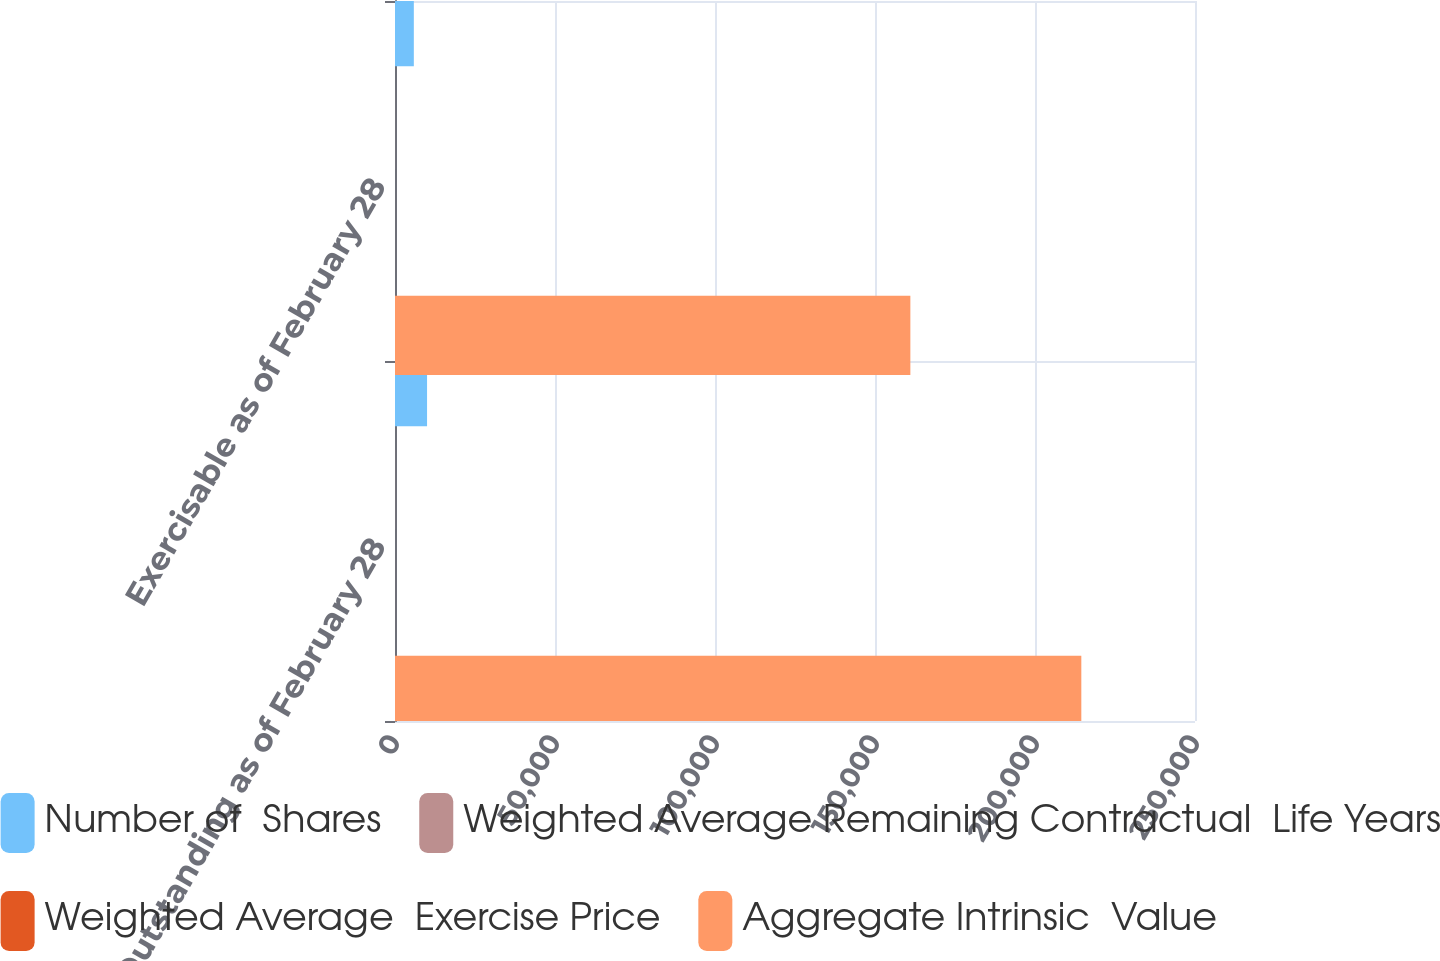<chart> <loc_0><loc_0><loc_500><loc_500><stacked_bar_chart><ecel><fcel>Outstanding as of February 28<fcel>Exercisable as of February 28<nl><fcel>Number of  Shares<fcel>10018<fcel>5883<nl><fcel>Weighted Average Remaining Contractual  Life Years<fcel>27.02<fcel>21.06<nl><fcel>Weighted Average  Exercise Price<fcel>3.7<fcel>2.6<nl><fcel>Aggregate Intrinsic  Value<fcel>214476<fcel>161051<nl></chart> 